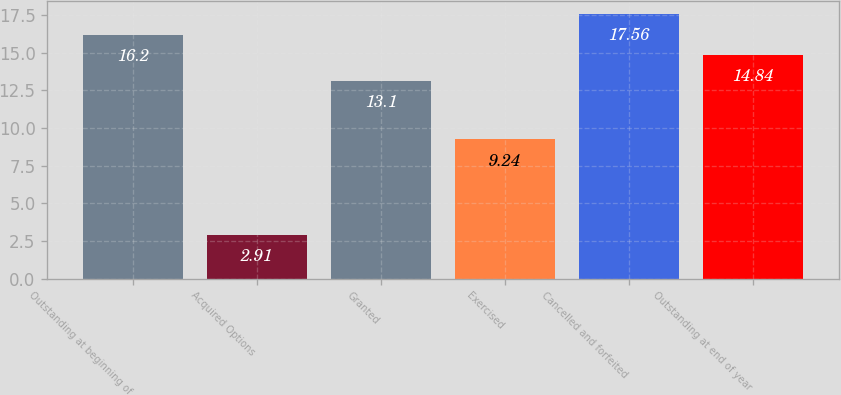<chart> <loc_0><loc_0><loc_500><loc_500><bar_chart><fcel>Outstanding at beginning of<fcel>Acquired Options<fcel>Granted<fcel>Exercised<fcel>Cancelled and forfeited<fcel>Outstanding at end of year<nl><fcel>16.2<fcel>2.91<fcel>13.1<fcel>9.24<fcel>17.56<fcel>14.84<nl></chart> 